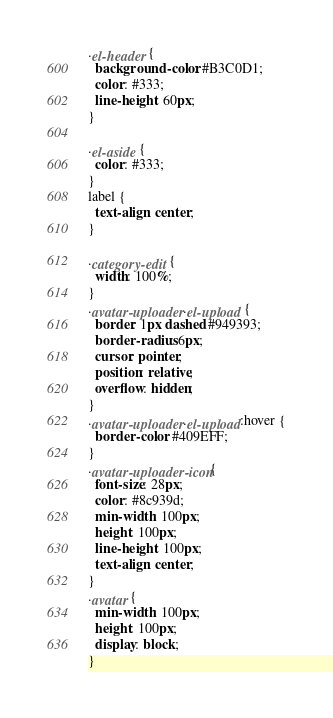Convert code to text. <code><loc_0><loc_0><loc_500><loc_500><_CSS_>.el-header {
  background-color: #B3C0D1;
  color: #333;
  line-height: 60px;
}

.el-aside {
  color: #333;
}
label {
  text-align: center;
}

.category-edit {
  width: 100%;
}
.avatar-uploader .el-upload {
  border: 1px dashed #949393;
  border-radius: 6px;
  cursor: pointer;
  position: relative;
  overflow: hidden;
}
.avatar-uploader .el-upload:hover {
  border-color: #409EFF;
}
.avatar-uploader-icon {
  font-size: 28px;
  color: #8c939d;
  min-width: 100px;
  height: 100px;
  line-height: 100px;
  text-align: center;
}
.avatar {
  min-width: 100px;
  height: 100px;
  display: block;
}</code> 